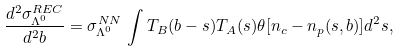Convert formula to latex. <formula><loc_0><loc_0><loc_500><loc_500>\frac { d ^ { 2 } \sigma _ { \Lambda ^ { 0 } } ^ { R E C } } { d ^ { 2 } b } = \sigma _ { \Lambda ^ { 0 } } ^ { N N } \, \int T _ { B } ( { b } - { s } ) T _ { A } ( { s } ) \theta [ n _ { c } - n _ { p } ( { s } , { b } ) ] d ^ { 2 } s ,</formula> 